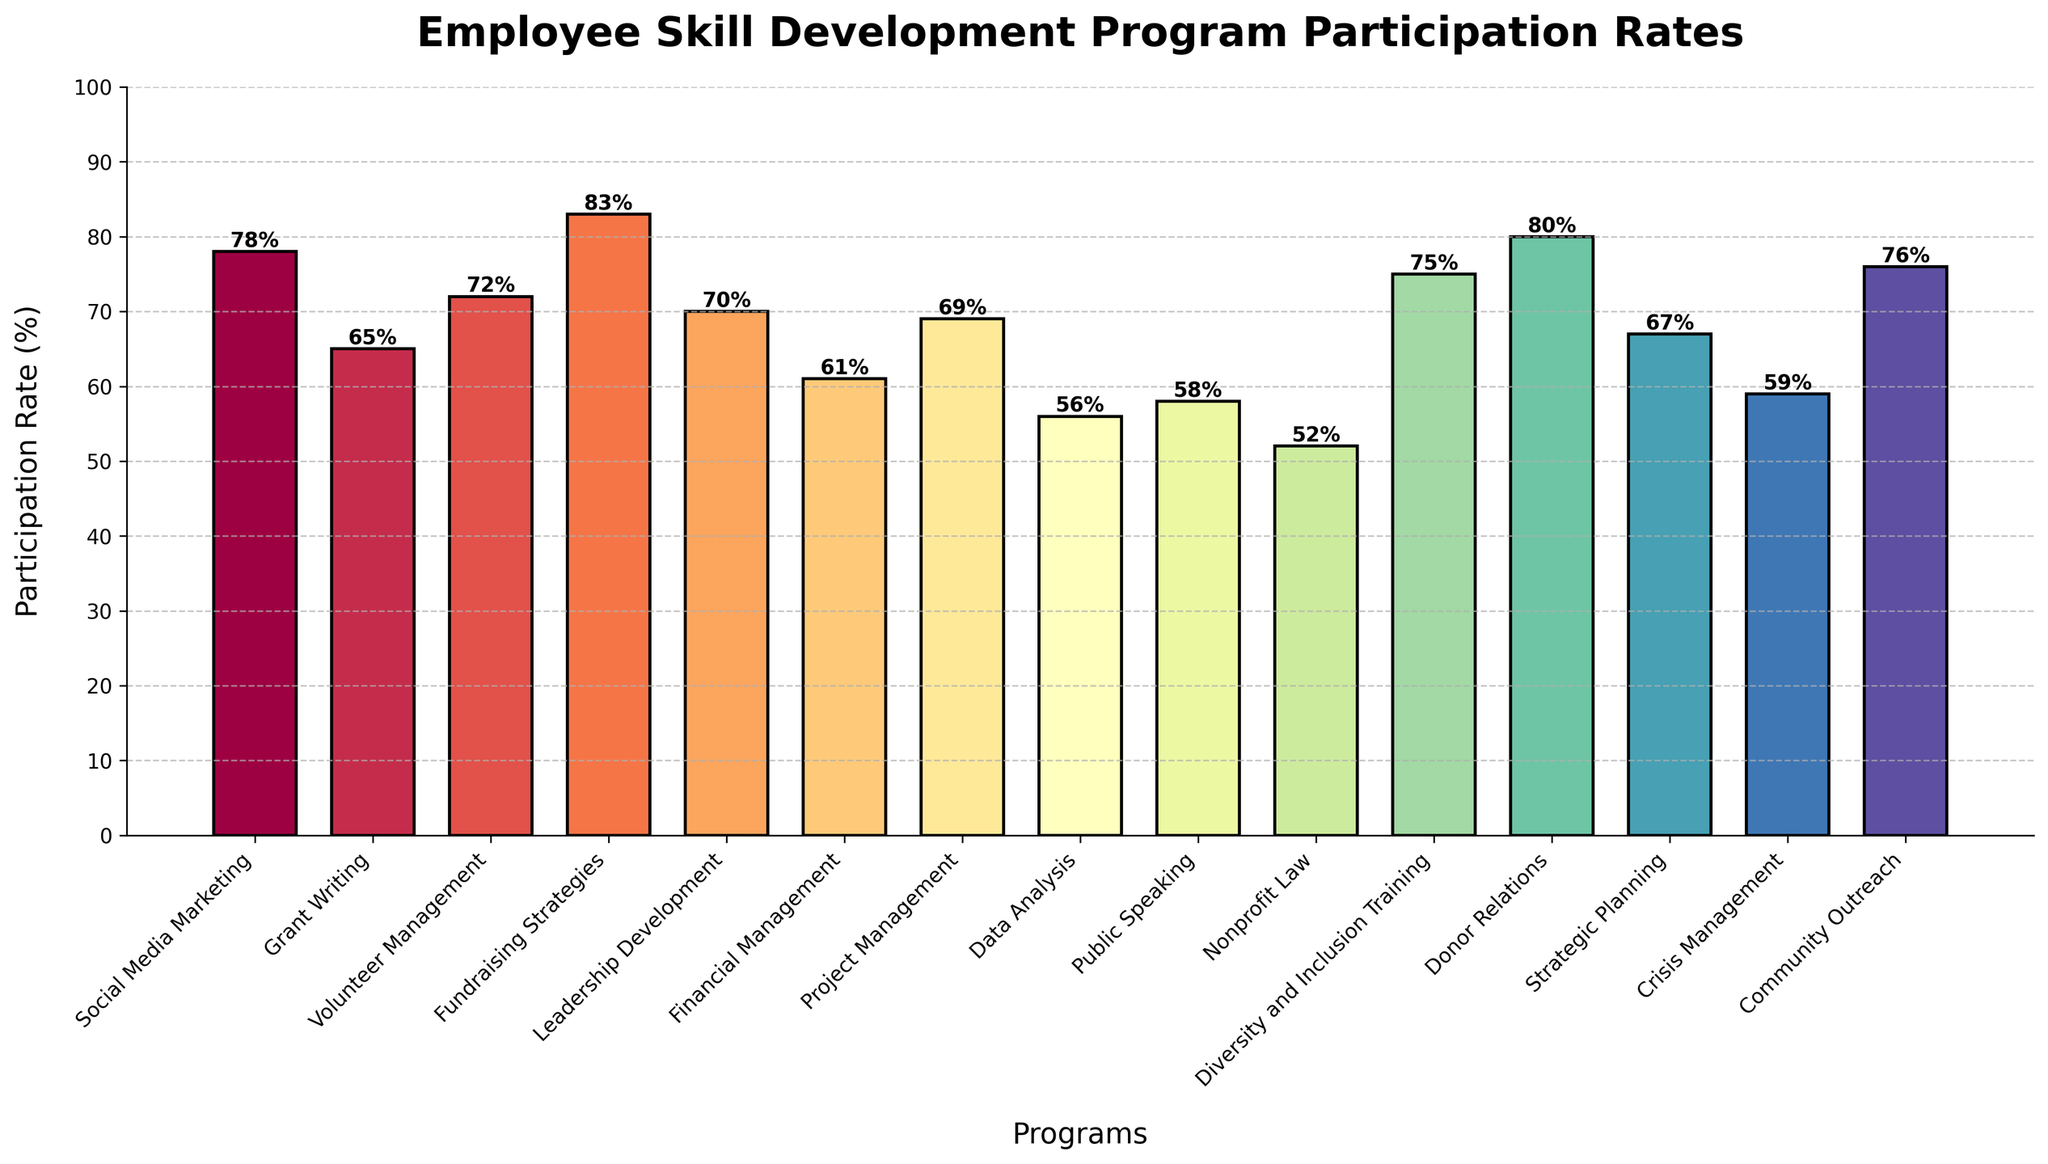Which program had the highest participation rate? The highest bar represents the program with the highest participation rate. The bar for Fundraising Strategies is the tallest.
Answer: Fundraising Strategies Compare the participation rates of Donor Relations and Financial Management. Which one is higher and by how much? Donor Relations has a participation rate of 80% and Financial Management has 61%. The difference is 80% - 61% = 19%.
Answer: Donor Relations by 19% What's the average participation rate for these programs? To find the average, sum all participation rates and divide by the number of programs: (78 + 65 + 72 + 83 + 70 + 61 + 69 + 56 + 58 + 52 + 75 + 80 + 67 + 59 + 76) / 15 = 70.66 (approximately).
Answer: 70.66 Which programs have a participation rate below 60%? Identify the bars below the 60% line. Data Analysis, Public Speaking, Nonprofit Law, and Crisis Management have participation rates of 56%, 58%, 52%, and 59% respectively.
Answer: Data Analysis, Public Speaking, Nonprofit Law, Crisis Management Is the participation rate for Leadership Development higher or lower than the average rate? The participation rate for Leadership Development is 70%. The average rate is approximately 70.66%. Since 70% < 70.66%, Leadership Development is slightly below the average.
Answer: Lower Which program has a participation rate closest to the midpoint between the highest and lowest rates? The highest rate is 83% and the lowest is 52%. The midpoint is (83 + 52) / 2 = 67.5%. The program closest to 67.5% is Strategic Planning at 67%.
Answer: Strategic Planning What is the total participation rate for Social Media Marketing, Volunteer Management, and Community Outreach combined? Sum the participation rates for the three programs: 78% + 72% + 76% = 226%.
Answer: 226% How many programs have a participation rate of 70% or more? Count the bars at or above the 70% line: Social Media Marketing, Volunteer Management, Fundraising Strategies, Leadership Development, Diversity and Inclusion Training, Donor Relations, Community Outreach.
Answer: 7 programs Is there a greater difference in participation rates between Strategic Planning and Project Management or between Grant Writing and Crisis Management? Calculate the differences: Strategic Planning (67%) and Project Management (69%) differ by 2%. Grant Writing (65%) and Crisis Management (59%) differ by 6%. 6% > 2%.
Answer: Grant Writing and Crisis Management What is the range of the participation rates? Subtract the lowest rate from the highest rate. The highest is 83% (Fundraising Strategies), and the lowest is 52% (Nonprofit Law). Range = 83% - 52% = 31%.
Answer: 31% 